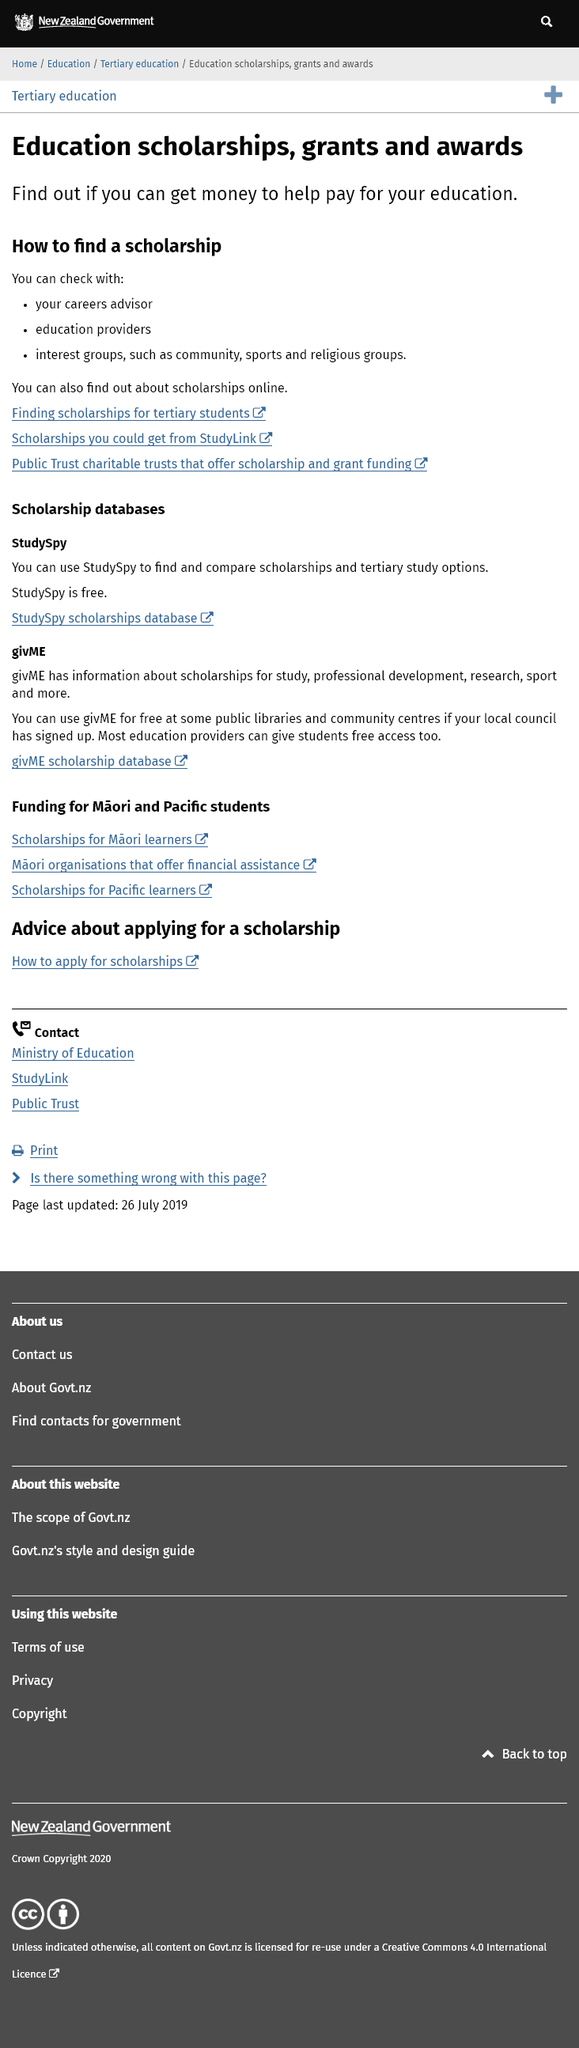Give some essential details in this illustration. It is possible to check with a careers advisor for a scholarship. 